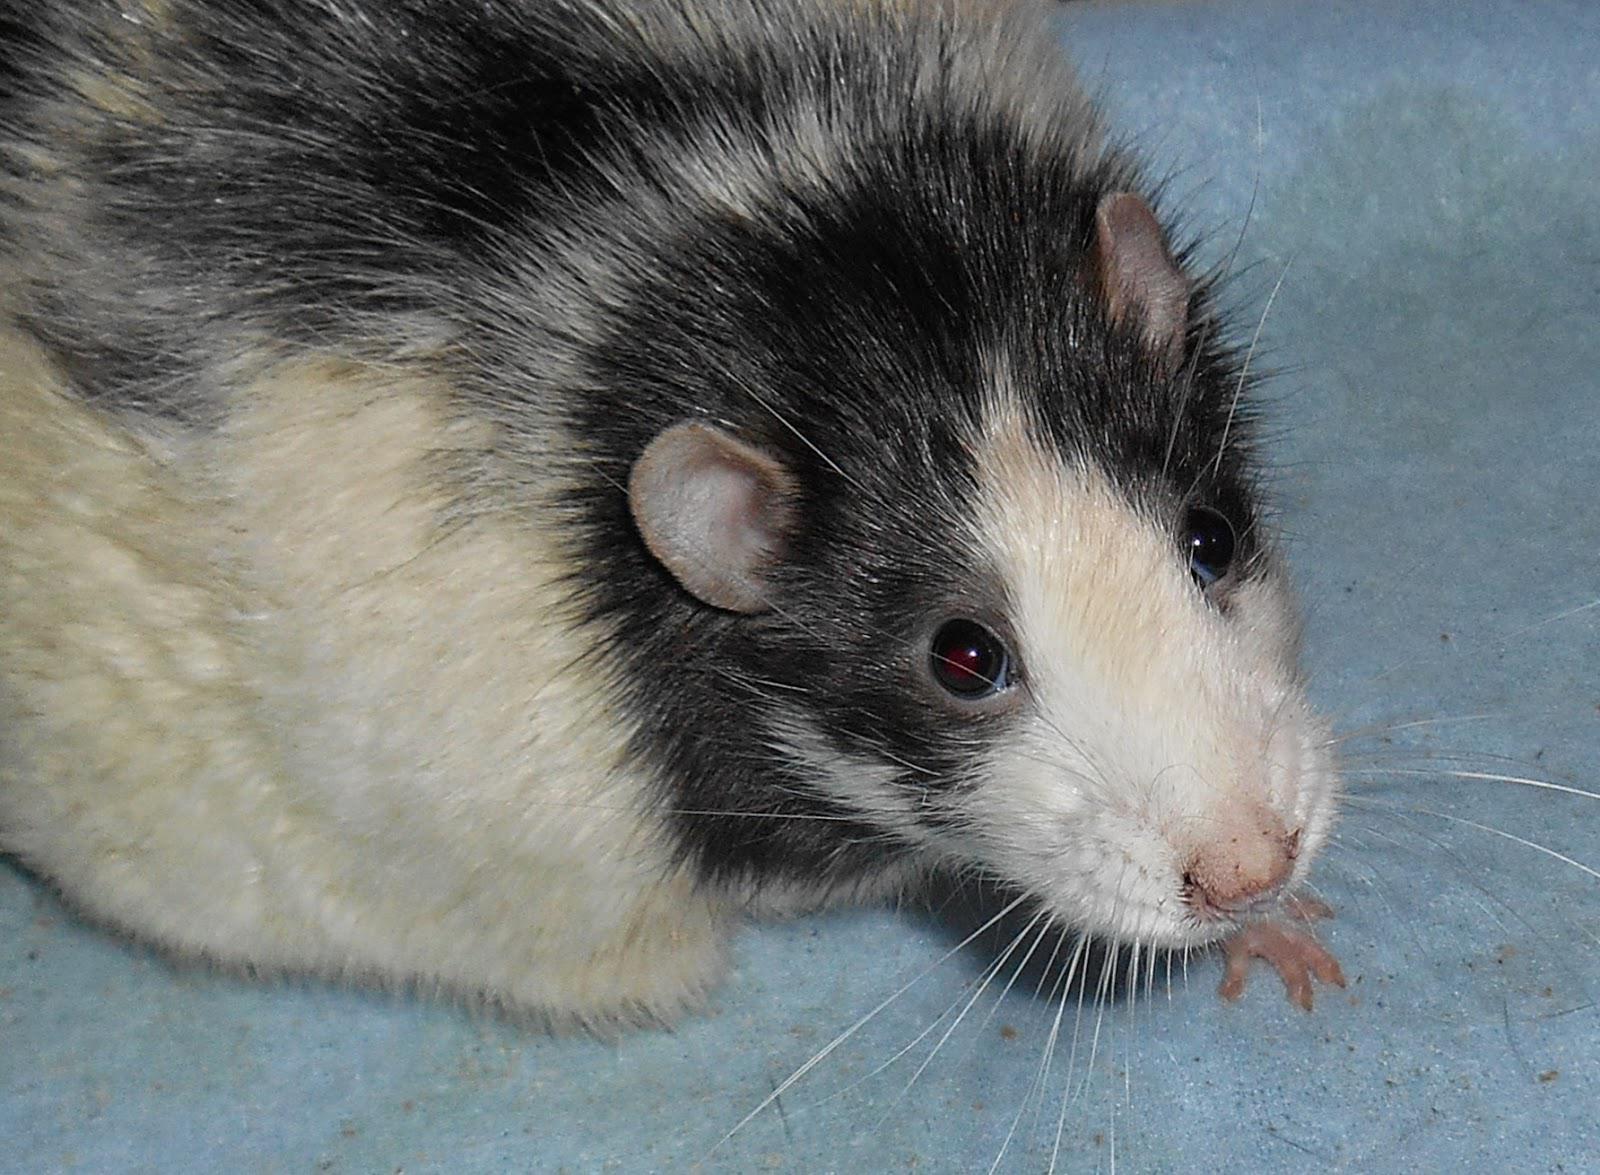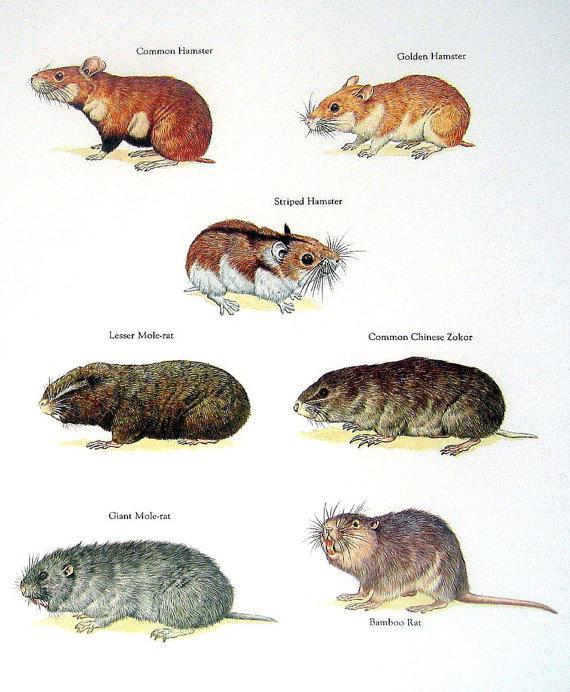The first image is the image on the left, the second image is the image on the right. Given the left and right images, does the statement "At least one of the animals is interacting with something." hold true? Answer yes or no. No. The first image is the image on the left, the second image is the image on the right. Considering the images on both sides, is "THere are at least two hamsters in the image on the right." valid? Answer yes or no. Yes. 